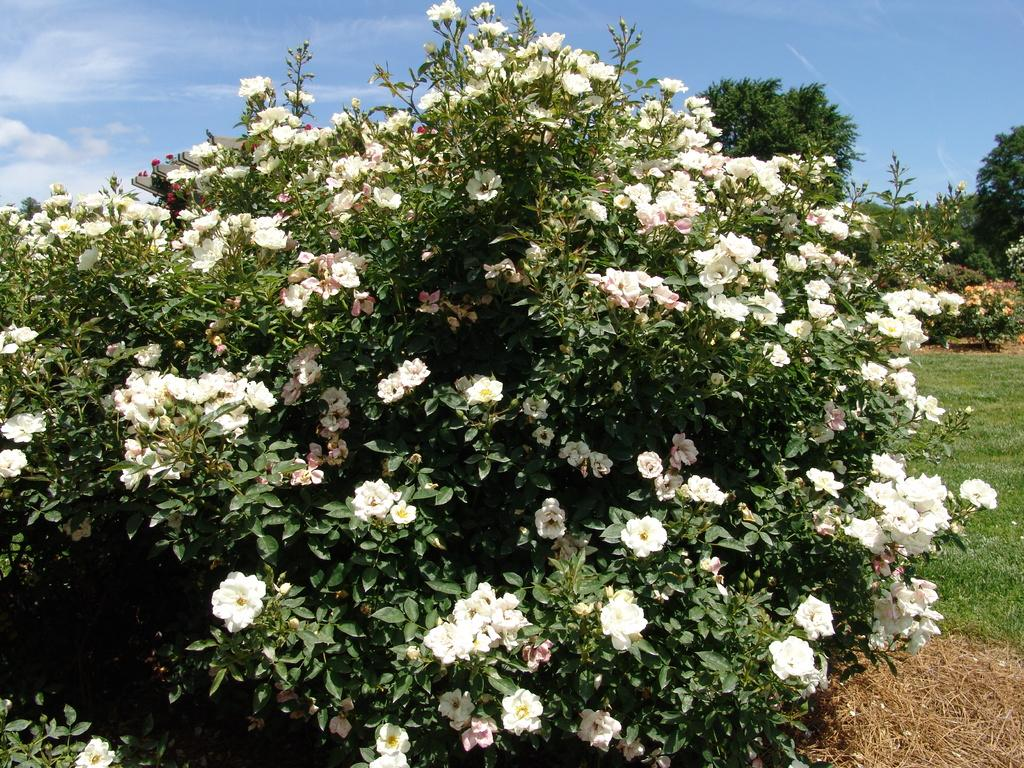What types of plants are in the foreground of the image? There are flowering plants and trees in the foreground of the image. What type of ground cover is present in the foreground of the image? There is grass in the foreground of the image. What can be seen in the background of the image? The sky is visible at the top of the image. Where was the image taken? The image was taken in a garden. What type of good-bye is being said in the image? There is no indication of anyone saying good-bye in the image. What selection of plants is being shown in the image? The image does not show a selection of plants; it simply depicts flowering plants, trees, and grass in a garden setting. 